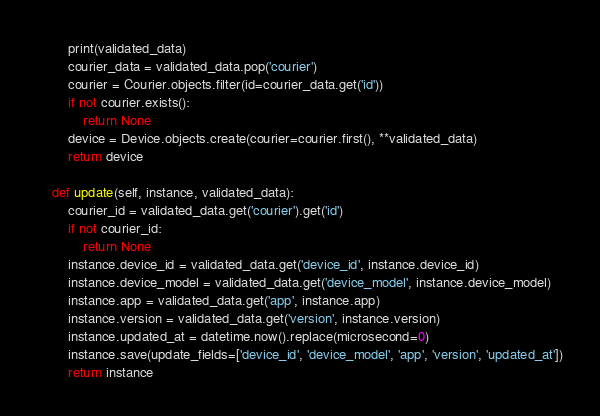<code> <loc_0><loc_0><loc_500><loc_500><_Python_>        print(validated_data)
        courier_data = validated_data.pop('courier')
        courier = Courier.objects.filter(id=courier_data.get('id'))
        if not courier.exists():
            return None
        device = Device.objects.create(courier=courier.first(), **validated_data)
        return device
    
    def update(self, instance, validated_data):
        courier_id = validated_data.get('courier').get('id')
        if not courier_id:
            return None
        instance.device_id = validated_data.get('device_id', instance.device_id)
        instance.device_model = validated_data.get('device_model', instance.device_model)
        instance.app = validated_data.get('app', instance.app)
        instance.version = validated_data.get('version', instance.version)
        instance.updated_at = datetime.now().replace(microsecond=0)
        instance.save(update_fields=['device_id', 'device_model', 'app', 'version', 'updated_at'])
        return instance</code> 